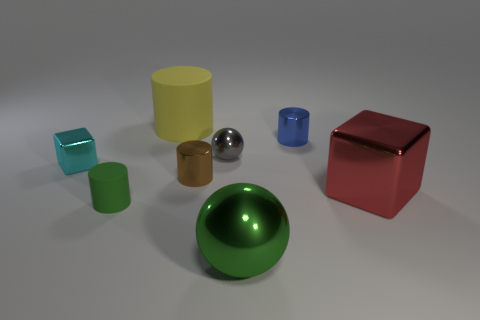Which object stands out the most and why? The red cube catches the eye immediately due to its vibrant color and reflective surface, creating a striking contrast against the more subdued tones of the other objects. 